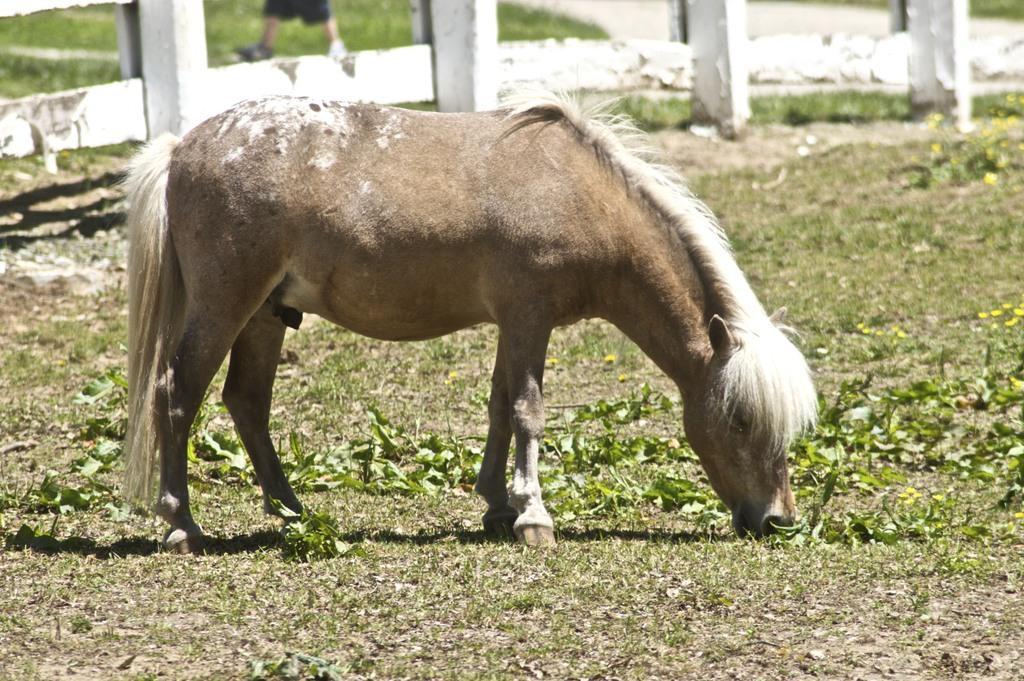Describe this image in one or two sentences. In the center of the picture there is a mule. In the foreground there is grass. In the center of the picture there are plants and grass. In the background there are railing, grass and a person's legs. 